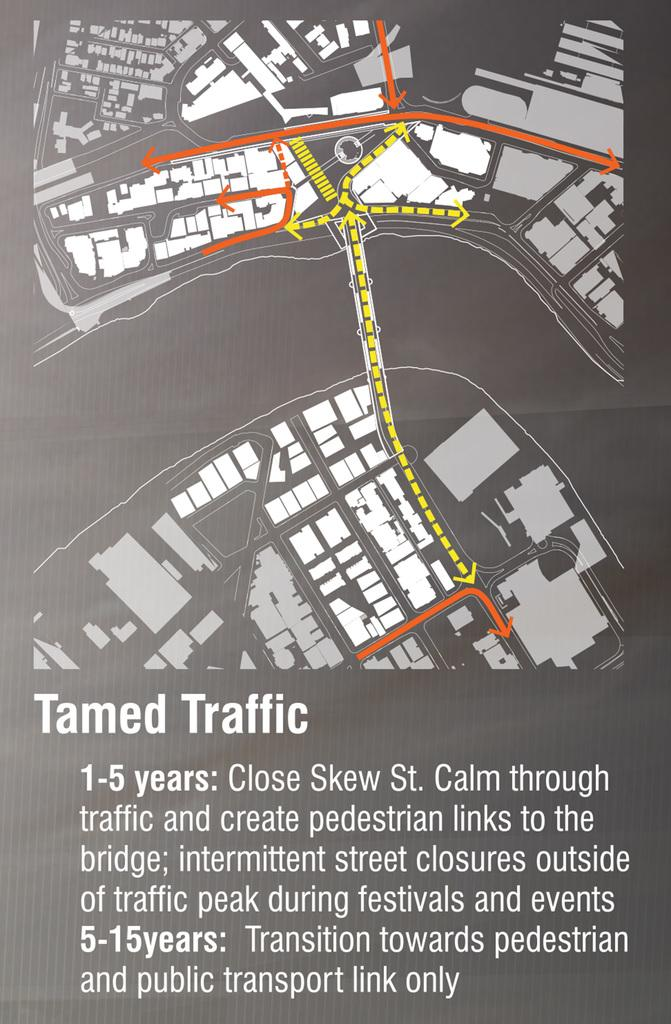<image>
Summarize the visual content of the image. tamed traffic sign that directs the traffic elsewhere 